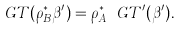Convert formula to latex. <formula><loc_0><loc_0><loc_500><loc_500>\ G T ( \rho _ { B } ^ { * } \beta ^ { \prime } ) = \rho _ { A } ^ { * } \ G T ^ { \prime } ( \beta ^ { \prime } ) .</formula> 